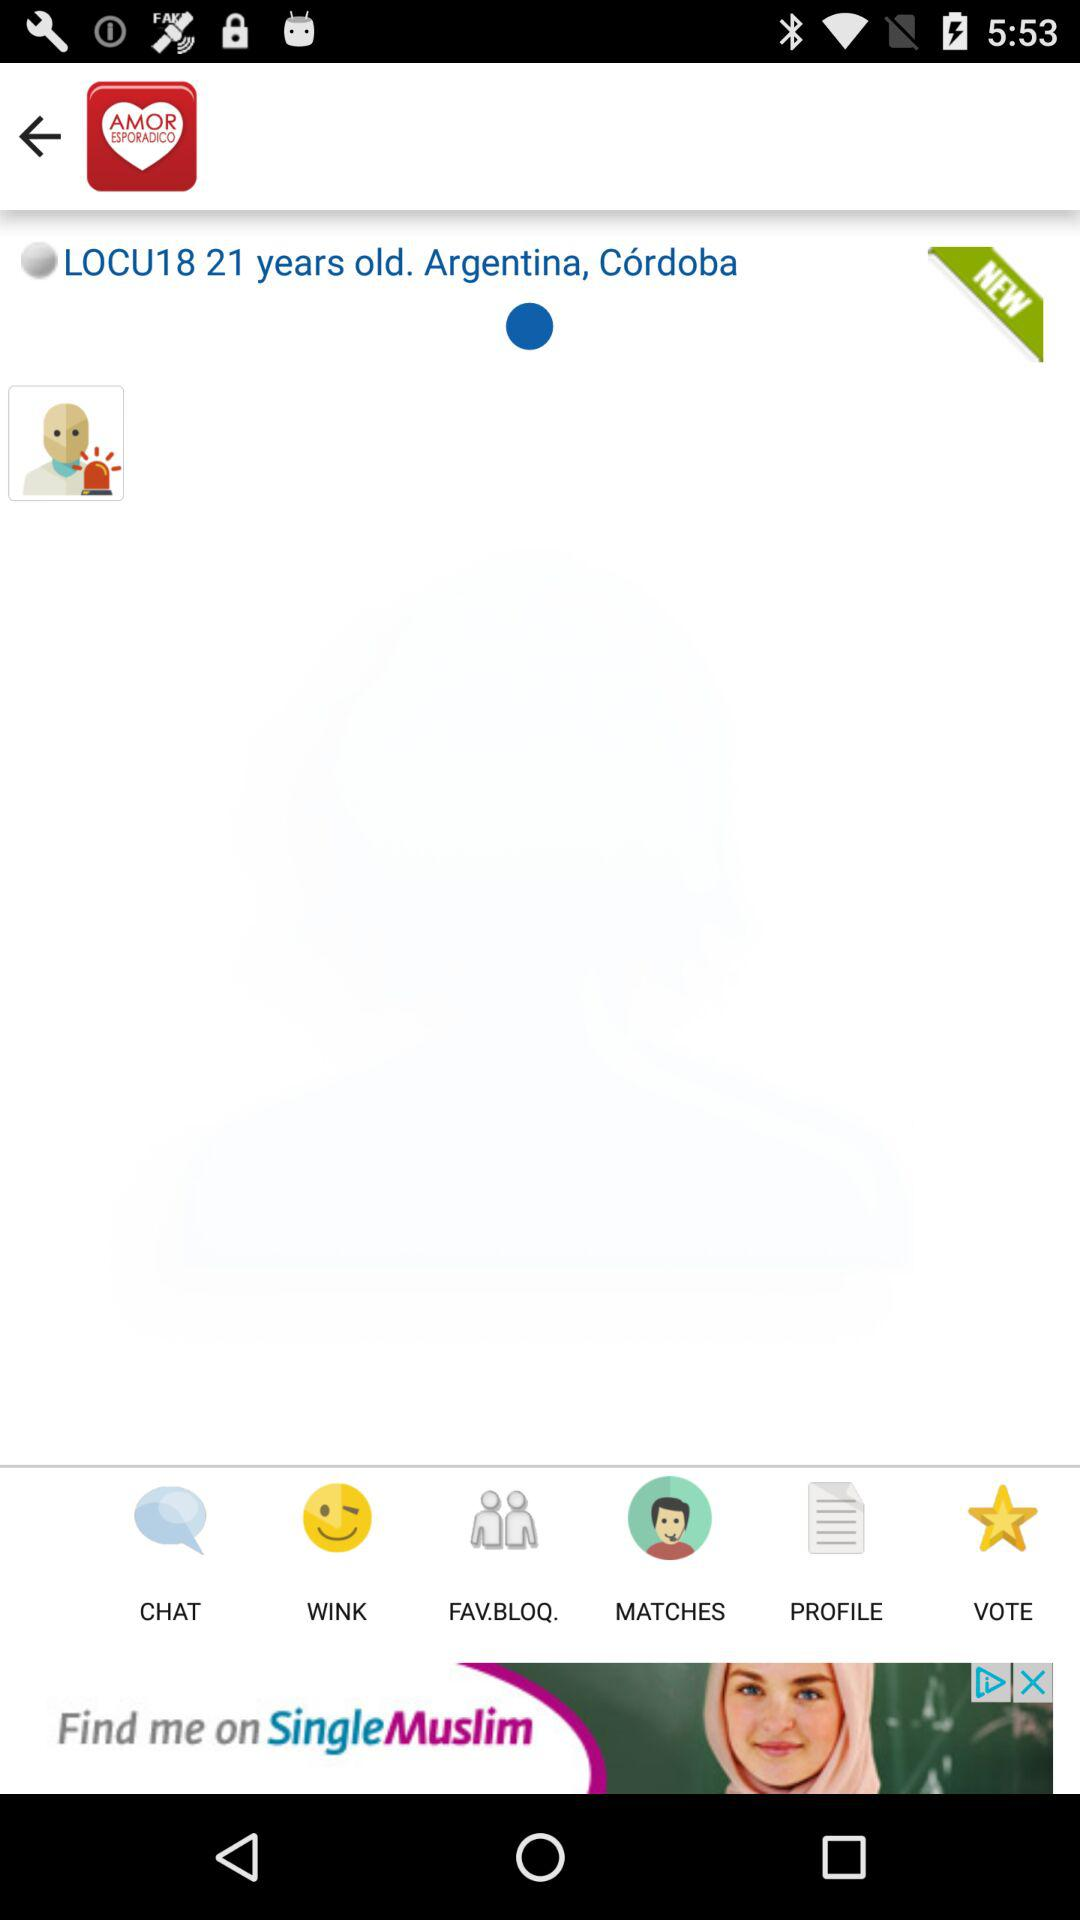What is the name of the user? The name of the user is LOCU18. 